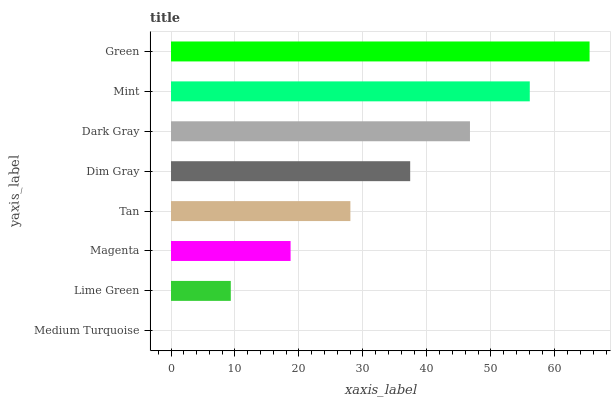Is Medium Turquoise the minimum?
Answer yes or no. Yes. Is Green the maximum?
Answer yes or no. Yes. Is Lime Green the minimum?
Answer yes or no. No. Is Lime Green the maximum?
Answer yes or no. No. Is Lime Green greater than Medium Turquoise?
Answer yes or no. Yes. Is Medium Turquoise less than Lime Green?
Answer yes or no. Yes. Is Medium Turquoise greater than Lime Green?
Answer yes or no. No. Is Lime Green less than Medium Turquoise?
Answer yes or no. No. Is Dim Gray the high median?
Answer yes or no. Yes. Is Tan the low median?
Answer yes or no. Yes. Is Tan the high median?
Answer yes or no. No. Is Medium Turquoise the low median?
Answer yes or no. No. 